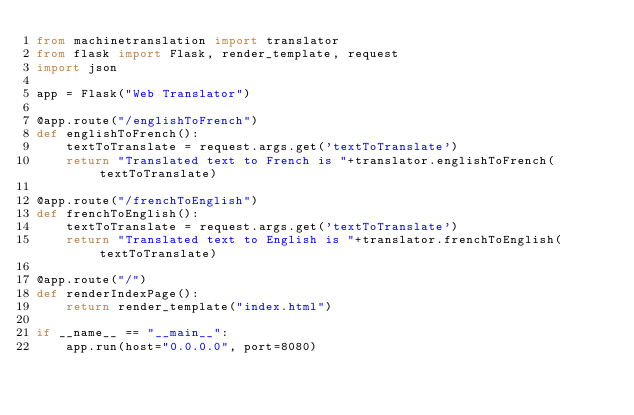<code> <loc_0><loc_0><loc_500><loc_500><_Python_>from machinetranslation import translator
from flask import Flask, render_template, request
import json

app = Flask("Web Translator")

@app.route("/englishToFrench")
def englishToFrench():
    textToTranslate = request.args.get('textToTranslate')
    return "Translated text to French is "+translator.englishToFrench(textToTranslate)

@app.route("/frenchToEnglish")
def frenchToEnglish():
    textToTranslate = request.args.get('textToTranslate')
    return "Translated text to English is "+translator.frenchToEnglish(textToTranslate)

@app.route("/")
def renderIndexPage():
    return render_template("index.html")

if __name__ == "__main__":
    app.run(host="0.0.0.0", port=8080)
</code> 